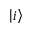<formula> <loc_0><loc_0><loc_500><loc_500>\left | i \right ></formula> 